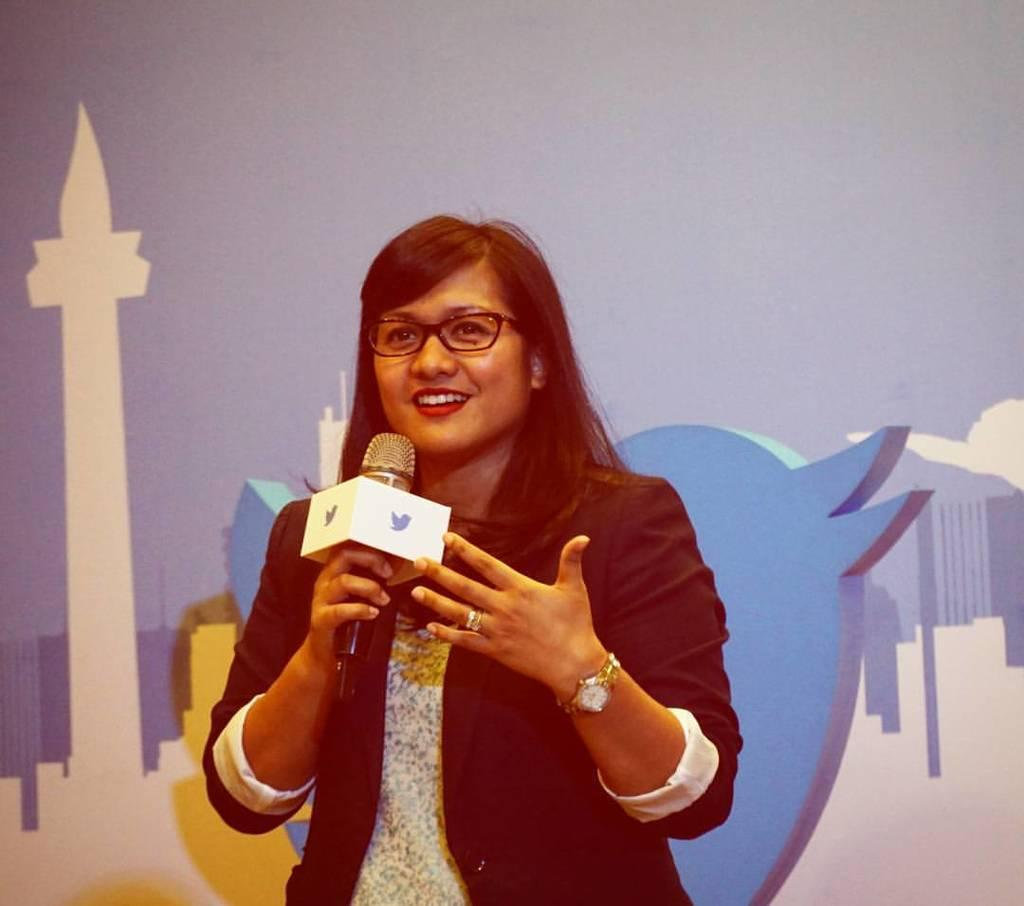Who is the main subject in the image? There is a woman in the image. What accessories is the woman wearing? The woman is wearing a watch and spectacles. What is the woman holding in her hand? The woman is holding a microphone in her hand. What can be seen in the background of the image? There is a painting on the wall in the background of the image. What type of whistle is the woman's partner using in the image? There is no partner or whistle present in the image. How does the woman's mom feel about her holding a microphone in the image? There is no mention of the woman's mom in the image, so it cannot be determined how she feels about the woman holding a microphone. 